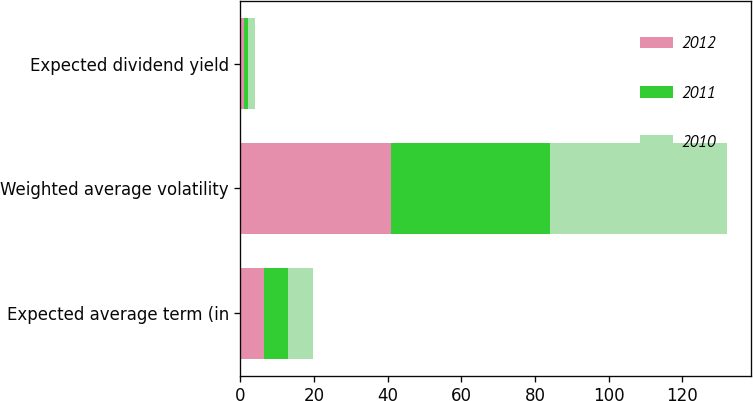Convert chart. <chart><loc_0><loc_0><loc_500><loc_500><stacked_bar_chart><ecel><fcel>Expected average term (in<fcel>Weighted average volatility<fcel>Expected dividend yield<nl><fcel>2012<fcel>6.3<fcel>41<fcel>1.1<nl><fcel>2011<fcel>6.5<fcel>43<fcel>1<nl><fcel>2010<fcel>6.9<fcel>48<fcel>1.8<nl></chart> 